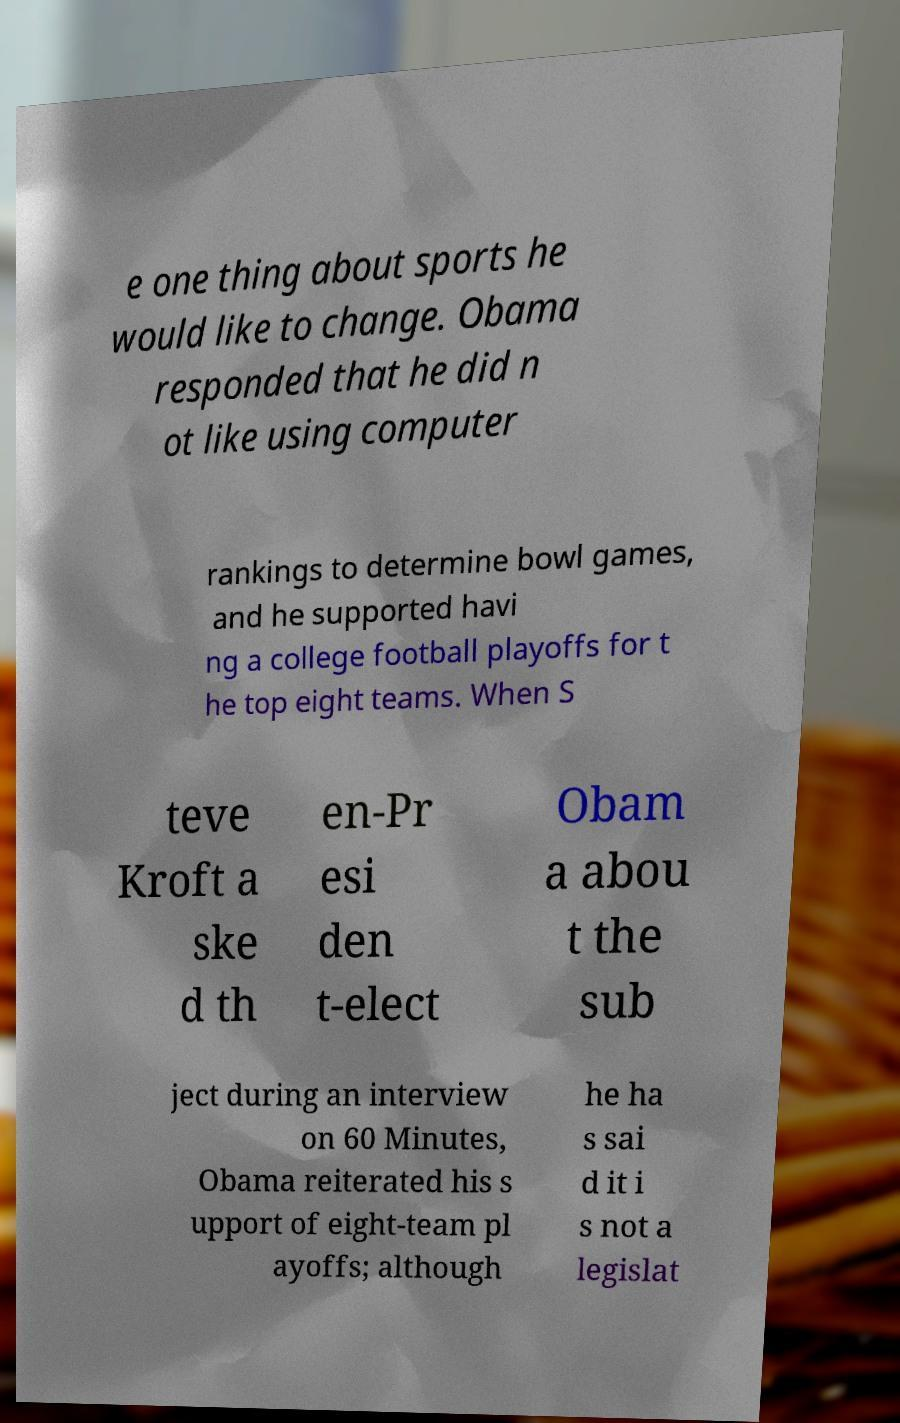What messages or text are displayed in this image? I need them in a readable, typed format. e one thing about sports he would like to change. Obama responded that he did n ot like using computer rankings to determine bowl games, and he supported havi ng a college football playoffs for t he top eight teams. When S teve Kroft a ske d th en-Pr esi den t-elect Obam a abou t the sub ject during an interview on 60 Minutes, Obama reiterated his s upport of eight-team pl ayoffs; although he ha s sai d it i s not a legislat 